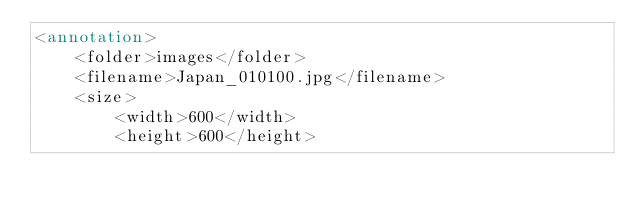<code> <loc_0><loc_0><loc_500><loc_500><_XML_><annotation>
	<folder>images</folder>
	<filename>Japan_010100.jpg</filename>
	<size>
		<width>600</width>
		<height>600</height></code> 